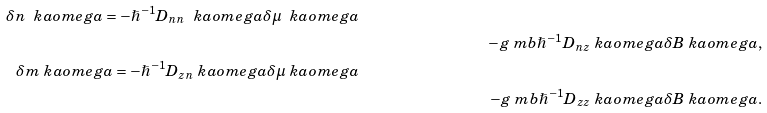<formula> <loc_0><loc_0><loc_500><loc_500>{ \delta n \ k a o m e g a = - \hslash ^ { - 1 } D _ { n n } \ k a o m e g a \delta \mu \ k a o m e g a } \\ & & - g \ m b \hslash ^ { - 1 } D _ { n z } \ k a o m e g a \delta B \ k a o m e g a , \\ { \delta m \ k a o m e g a = - \hslash ^ { - 1 } D _ { z n } \ k a o m e g a \delta \mu \ k a o m e g a } \\ & & - g \ m b \hslash ^ { - 1 } D _ { z z } \ k a o m e g a \delta B \ k a o m e g a .</formula> 